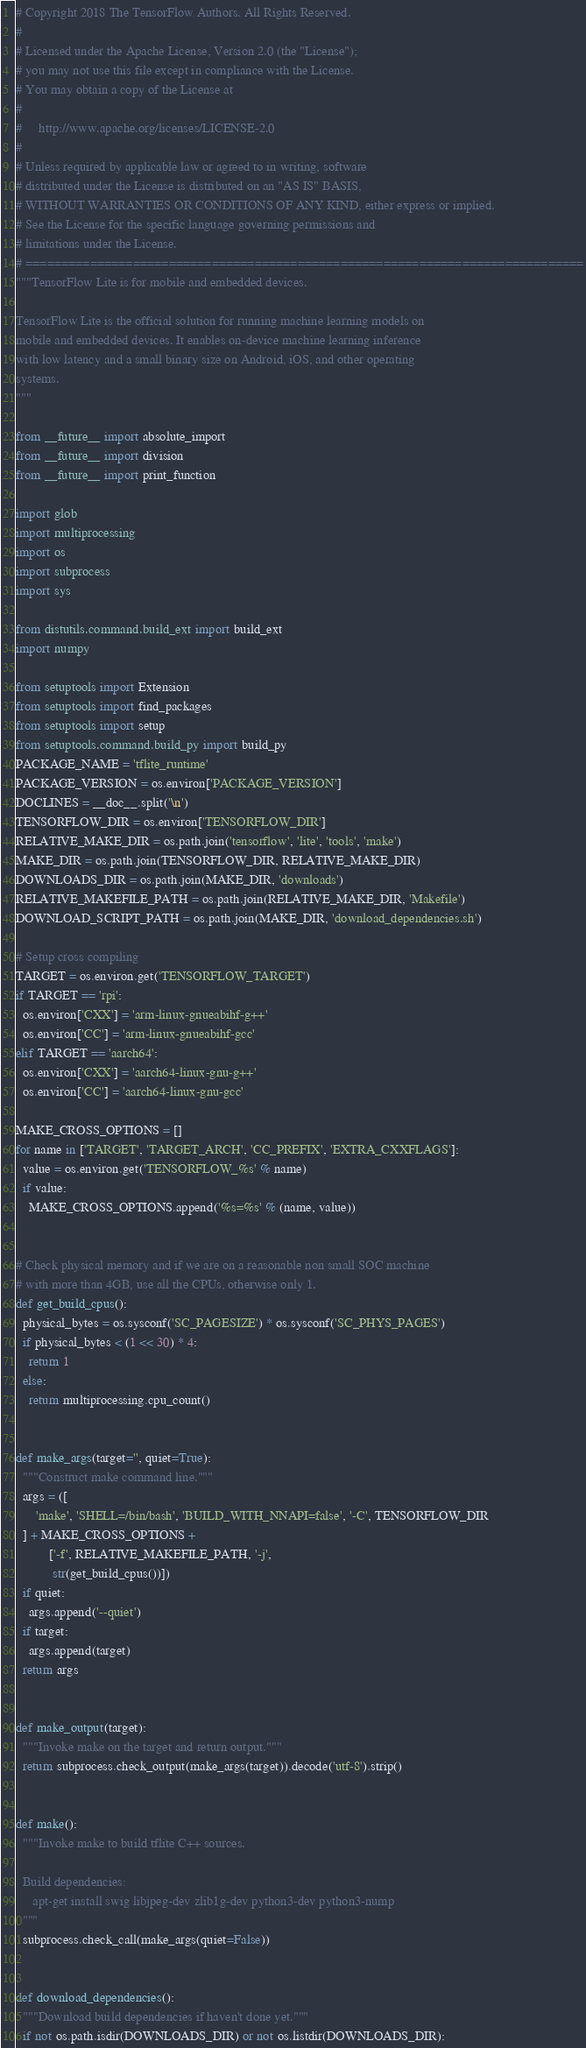Convert code to text. <code><loc_0><loc_0><loc_500><loc_500><_Python_># Copyright 2018 The TensorFlow Authors. All Rights Reserved.
#
# Licensed under the Apache License, Version 2.0 (the "License");
# you may not use this file except in compliance with the License.
# You may obtain a copy of the License at
#
#     http://www.apache.org/licenses/LICENSE-2.0
#
# Unless required by applicable law or agreed to in writing, software
# distributed under the License is distributed on an "AS IS" BASIS,
# WITHOUT WARRANTIES OR CONDITIONS OF ANY KIND, either express or implied.
# See the License for the specific language governing permissions and
# limitations under the License.
# ==============================================================================
"""TensorFlow Lite is for mobile and embedded devices.

TensorFlow Lite is the official solution for running machine learning models on
mobile and embedded devices. It enables on-device machine learning inference
with low latency and a small binary size on Android, iOS, and other operating
systems.
"""

from __future__ import absolute_import
from __future__ import division
from __future__ import print_function

import glob
import multiprocessing
import os
import subprocess
import sys

from distutils.command.build_ext import build_ext
import numpy

from setuptools import Extension
from setuptools import find_packages
from setuptools import setup
from setuptools.command.build_py import build_py
PACKAGE_NAME = 'tflite_runtime'
PACKAGE_VERSION = os.environ['PACKAGE_VERSION']
DOCLINES = __doc__.split('\n')
TENSORFLOW_DIR = os.environ['TENSORFLOW_DIR']
RELATIVE_MAKE_DIR = os.path.join('tensorflow', 'lite', 'tools', 'make')
MAKE_DIR = os.path.join(TENSORFLOW_DIR, RELATIVE_MAKE_DIR)
DOWNLOADS_DIR = os.path.join(MAKE_DIR, 'downloads')
RELATIVE_MAKEFILE_PATH = os.path.join(RELATIVE_MAKE_DIR, 'Makefile')
DOWNLOAD_SCRIPT_PATH = os.path.join(MAKE_DIR, 'download_dependencies.sh')

# Setup cross compiling
TARGET = os.environ.get('TENSORFLOW_TARGET')
if TARGET == 'rpi':
  os.environ['CXX'] = 'arm-linux-gnueabihf-g++'
  os.environ['CC'] = 'arm-linux-gnueabihf-gcc'
elif TARGET == 'aarch64':
  os.environ['CXX'] = 'aarch64-linux-gnu-g++'
  os.environ['CC'] = 'aarch64-linux-gnu-gcc'

MAKE_CROSS_OPTIONS = []
for name in ['TARGET', 'TARGET_ARCH', 'CC_PREFIX', 'EXTRA_CXXFLAGS']:
  value = os.environ.get('TENSORFLOW_%s' % name)
  if value:
    MAKE_CROSS_OPTIONS.append('%s=%s' % (name, value))


# Check physical memory and if we are on a reasonable non small SOC machine
# with more than 4GB, use all the CPUs, otherwise only 1.
def get_build_cpus():
  physical_bytes = os.sysconf('SC_PAGESIZE') * os.sysconf('SC_PHYS_PAGES')
  if physical_bytes < (1 << 30) * 4:
    return 1
  else:
    return multiprocessing.cpu_count()


def make_args(target='', quiet=True):
  """Construct make command line."""
  args = ([
      'make', 'SHELL=/bin/bash', 'BUILD_WITH_NNAPI=false', '-C', TENSORFLOW_DIR
  ] + MAKE_CROSS_OPTIONS +
          ['-f', RELATIVE_MAKEFILE_PATH, '-j',
           str(get_build_cpus())])
  if quiet:
    args.append('--quiet')
  if target:
    args.append(target)
  return args


def make_output(target):
  """Invoke make on the target and return output."""
  return subprocess.check_output(make_args(target)).decode('utf-8').strip()


def make():
  """Invoke make to build tflite C++ sources.

  Build dependencies:
     apt-get install swig libjpeg-dev zlib1g-dev python3-dev python3-nump
  """
  subprocess.check_call(make_args(quiet=False))


def download_dependencies():
  """Download build dependencies if haven't done yet."""
  if not os.path.isdir(DOWNLOADS_DIR) or not os.listdir(DOWNLOADS_DIR):</code> 